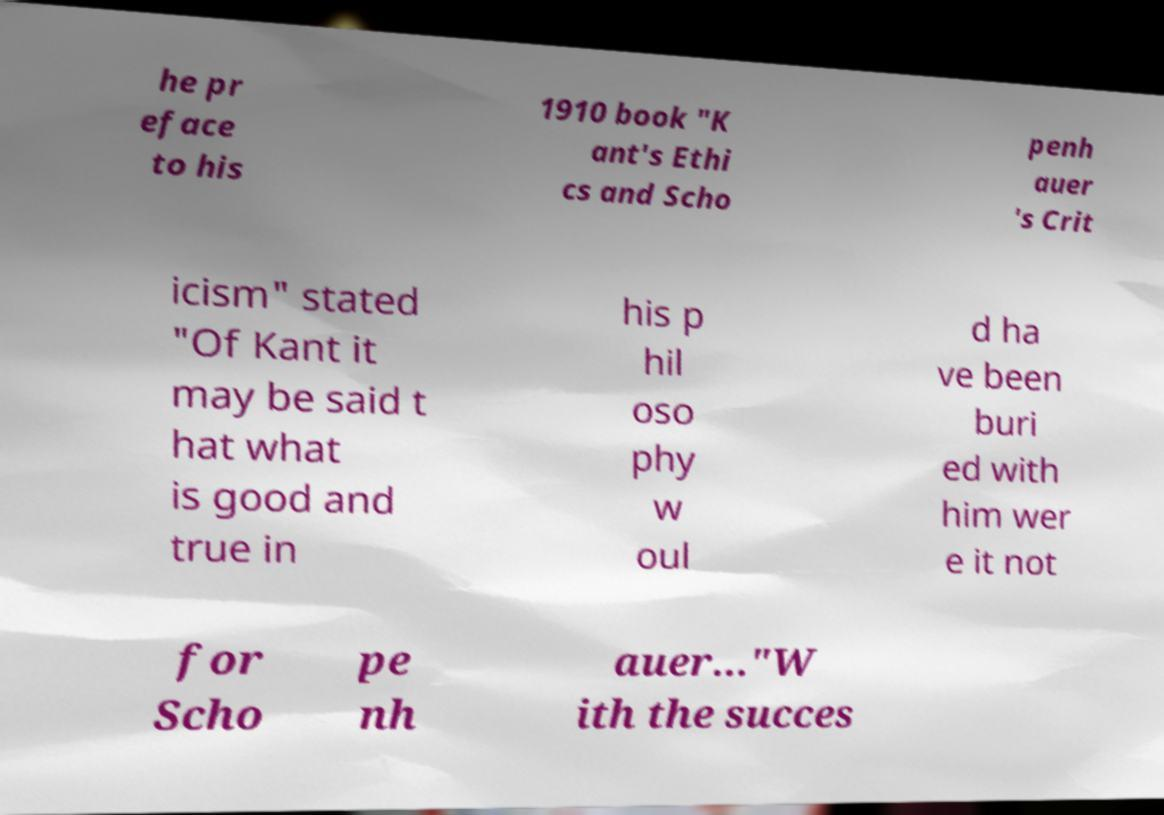Can you accurately transcribe the text from the provided image for me? he pr eface to his 1910 book "K ant's Ethi cs and Scho penh auer 's Crit icism" stated "Of Kant it may be said t hat what is good and true in his p hil oso phy w oul d ha ve been buri ed with him wer e it not for Scho pe nh auer..."W ith the succes 